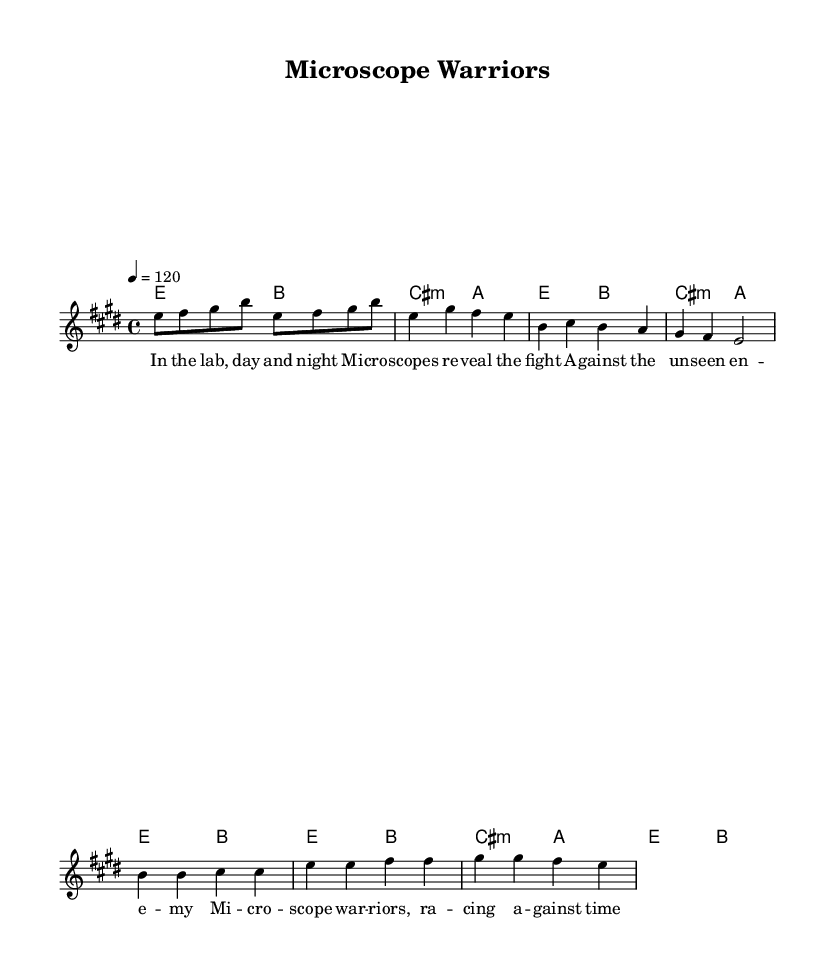What is the key signature of this music? The key signature is E major, which has four sharps (F#, C#, G#, and D#).
Answer: E major What is the time signature of the piece? The time signature shown at the beginning of the score is 4/4, indicating four beats per measure.
Answer: 4/4 What is the tempo marking for this music? The tempo marking indicates a tempo of 120 beats per minute, referring to the quarter note.
Answer: 120 How many measures are there in the chorus? By counting the number of measures in the chorus section, it's evident that there are four measures.
Answer: 4 What is the main theme of the lyrics in the verse? Analyzing the lyrics, the main theme expresses the relentless work and struggle in vaccine research portrayed as a fight against an unseen enemy.
Answer: Fighting unseen enemy What is the primary musical texture of this piece? The texture is primarily homophonic, with a lead melody supported by chords, emphasizing the melody line throughout.
Answer: Homophonic What title is given to this musical composition? The title provided at the top of the music score is "Microscope Warriors," reflecting its theme about vaccine researchers.
Answer: Microscope Warriors 